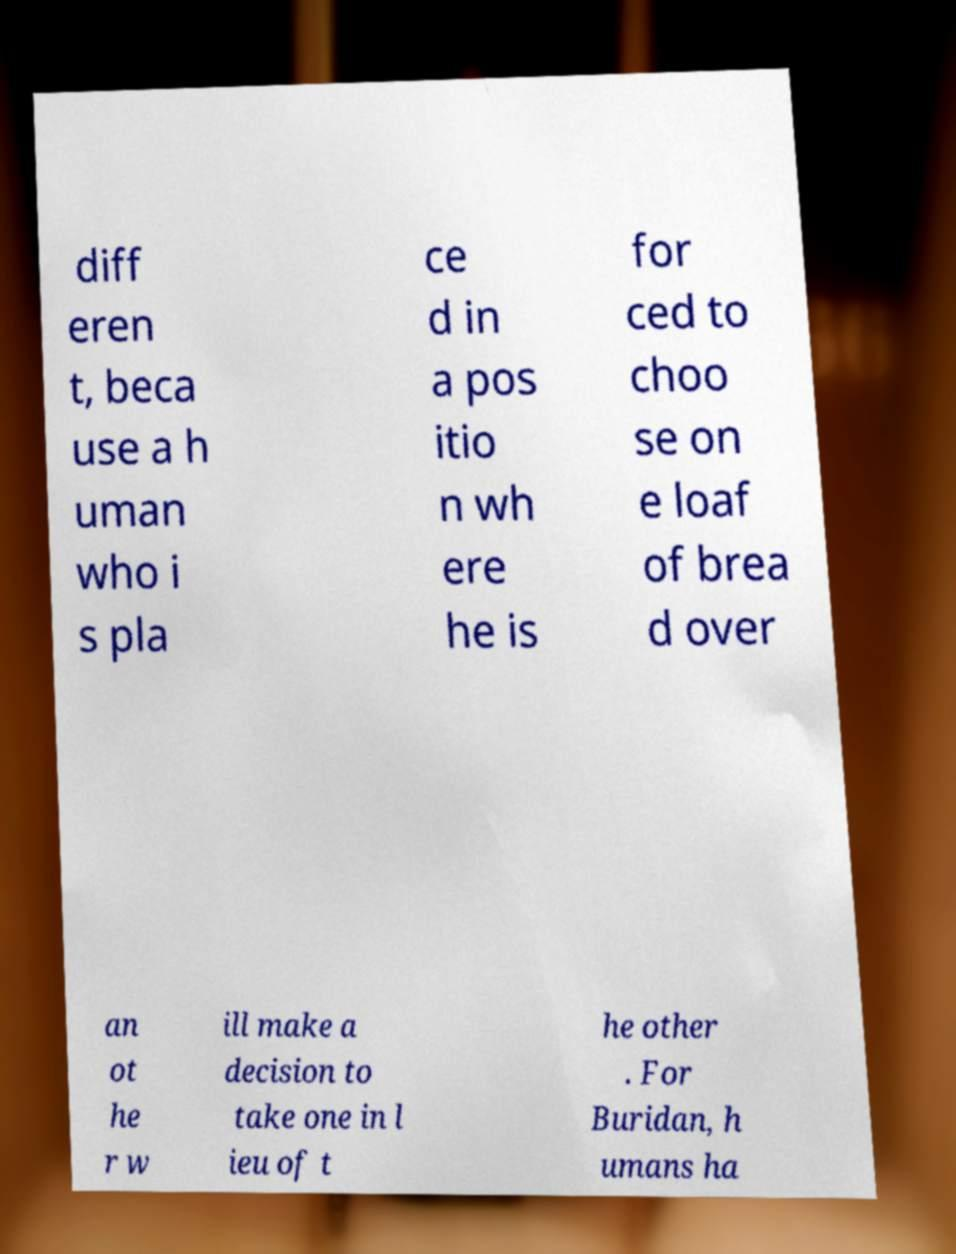Please read and relay the text visible in this image. What does it say? diff eren t, beca use a h uman who i s pla ce d in a pos itio n wh ere he is for ced to choo se on e loaf of brea d over an ot he r w ill make a decision to take one in l ieu of t he other . For Buridan, h umans ha 